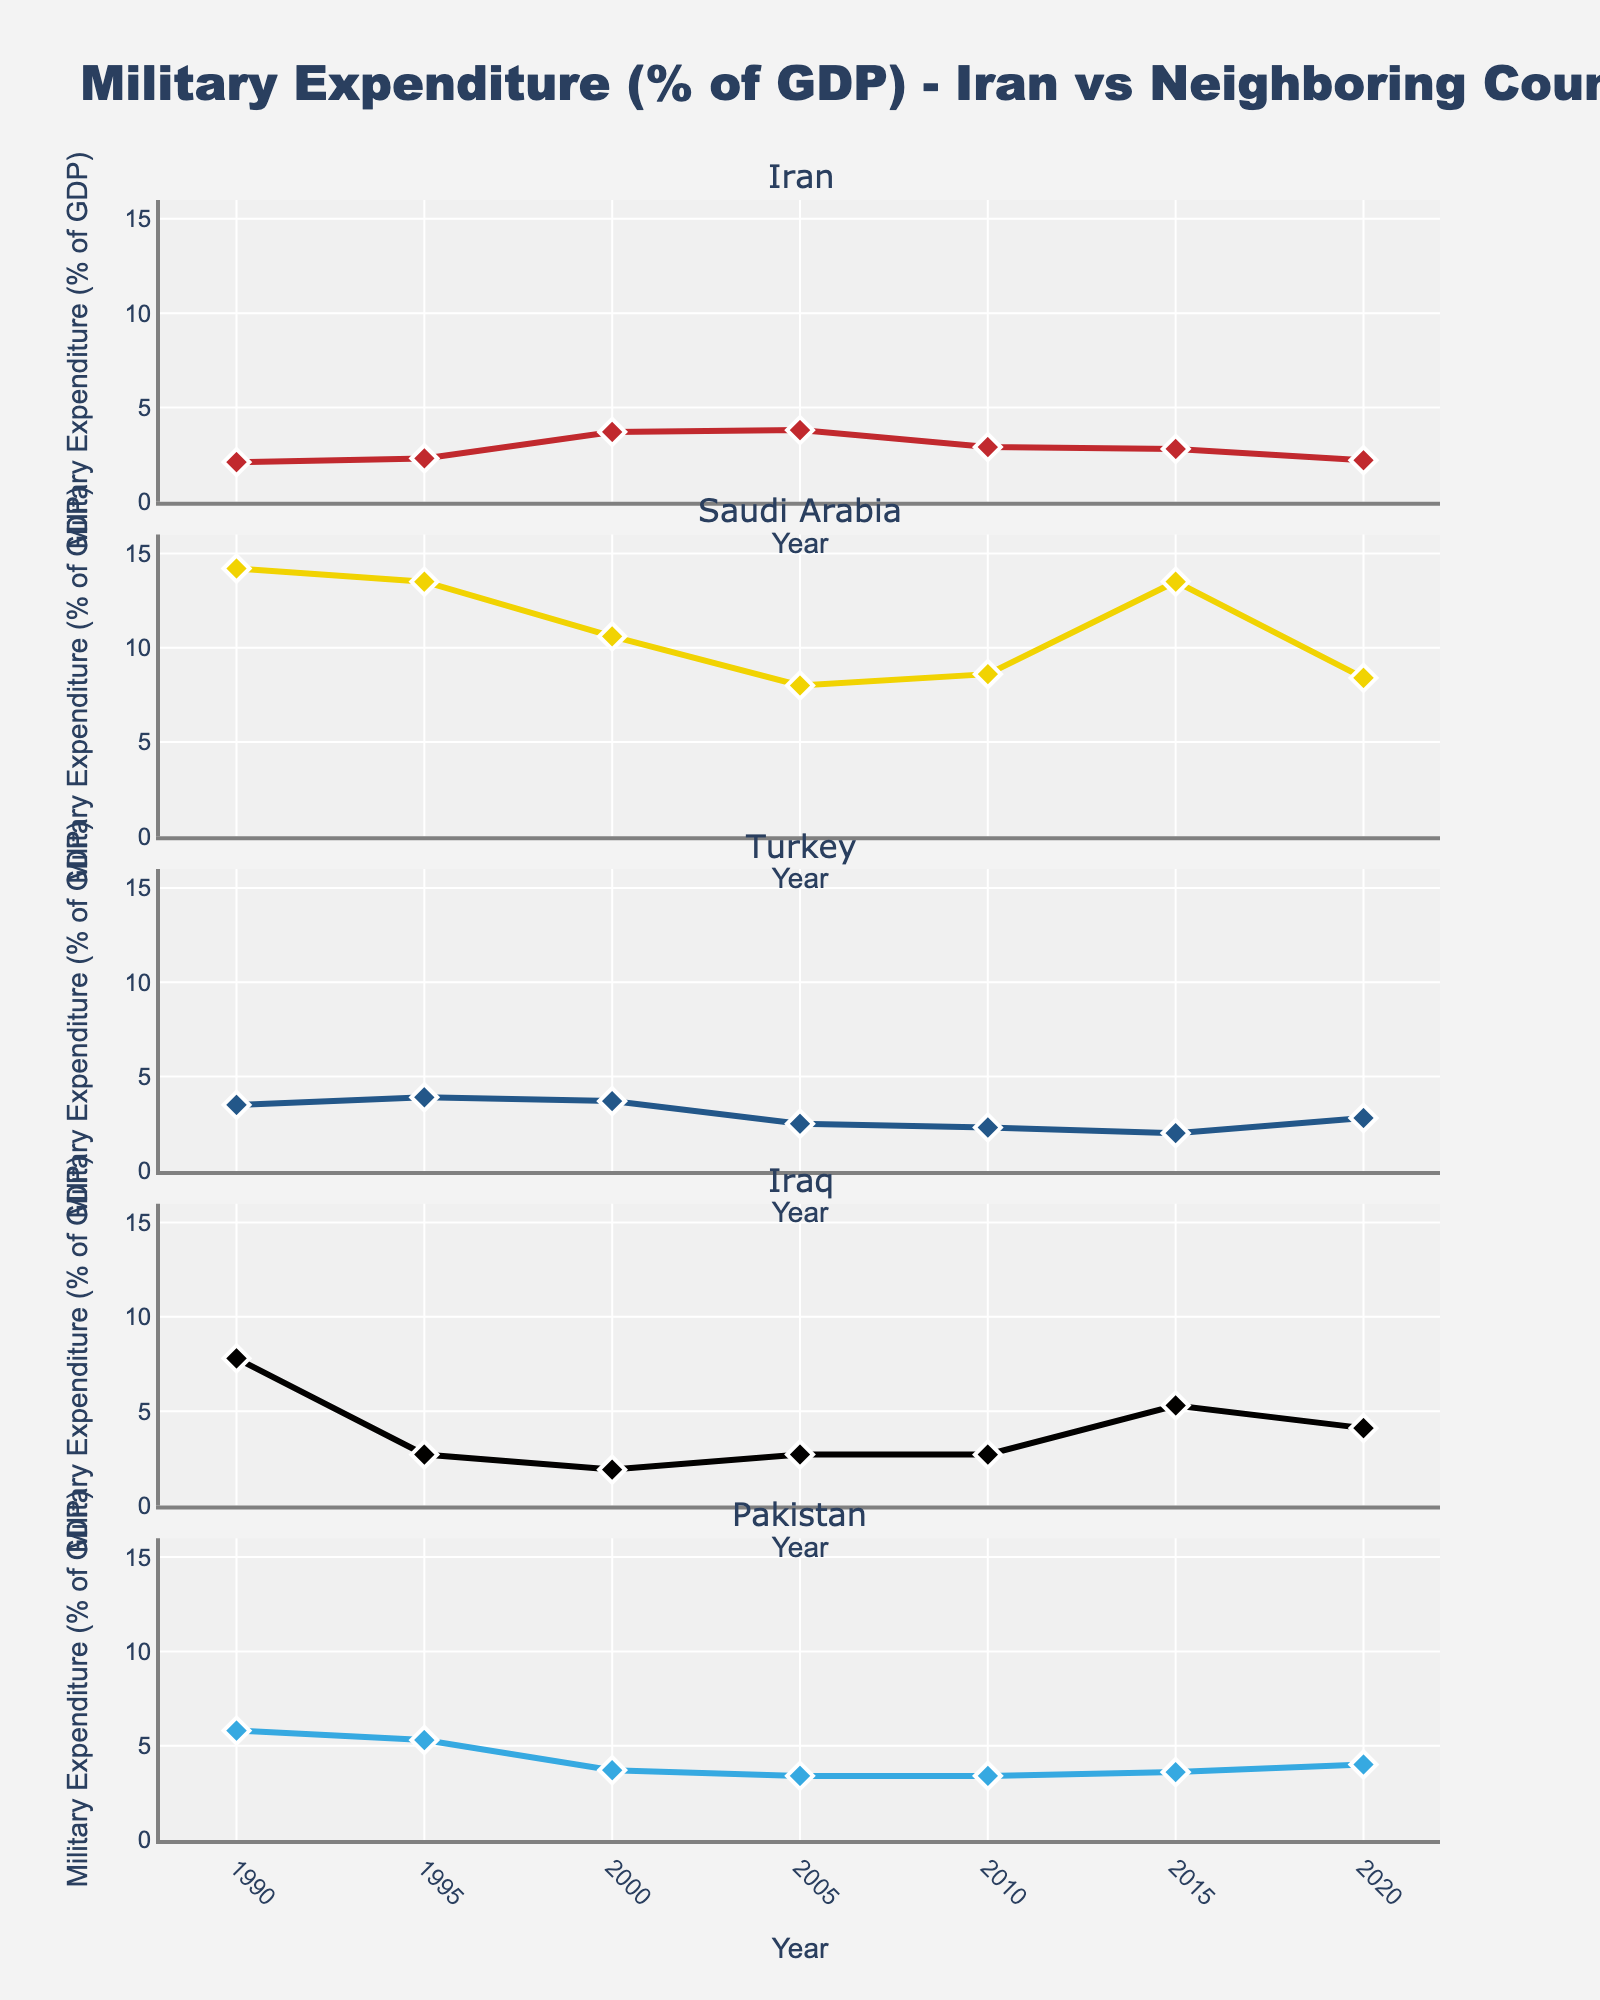How many countries are compared in the figure? The figure compares the military expenditure of five countries, as indicated by the subplot titles.
Answer: Five What is the overall trend of Iran's military expenditure over the past 30 years? To identify the trend, observe the line for Iran across the years. The line shows slight fluctuations but generally a stable to slightly declining trend from around 2.1% in 1990 to 2.2% in 2020.
Answer: Slightly declining During which year did Saudi Arabia have the highest military expenditure? Check the line corresponding to Saudi Arabia and identify the year when its percentage was the highest. In 1990, the value was 14.2, which is the highest point.
Answer: 1990 Which country had the lowest military expenditure in 2000? Compare the data points for each country in the year 2000. Iraq has the lowest value at 1.9%.
Answer: Iraq How does Iran's military expenditure in 2020 compare to Turkey's in the same year? For 2020, Iran has an expenditure of 2.2% while Turkey has 2.8%. Comparing these percentages, Turkey's expenditure is higher.
Answer: Turkey's is higher What is the average military expenditure of Pakistan over the 30 years? Sum the expenditures of Pakistan from each year and divide by the number of years. (5.8 + 5.3 + 3.7 + 3.4 + 3.4 + 3.6 + 4.0) / 7 = 4.46%.
Answer: 4.46% Which two years had the closest military expenditure values for Iraq, and what were those values? Identify the years where values for Iraq are closest. 2005 and 2010 both have a value of 2.7%.
Answer: 2005 and 2010, both 2.7% Has there been any year when Iran's military expenditure was higher than Pakistan's? Compare the percentages of Iran and Pakistan for each year. In 2000, Iran's expenditure (3.7%) was higher than Pakistan's (3.7%).
Answer: Yes, in 2000 Which country exhibited the most fluctuation in military expenditure over the years? By examining the lines, Saudi Arabia's values range from 8.0% to 14.2%, indicating significant fluctuation.
Answer: Saudi Arabia What is the median military expenditure of Turkey over the observed period? Rank the expenditures of Turkey from lowest to highest and identify the middle value: 2.0%, 2.3%, 2.5%, 2.8%, 3.5%, 3.7%, 3.9%. The median value is 2.8%.
Answer: 2.8% 